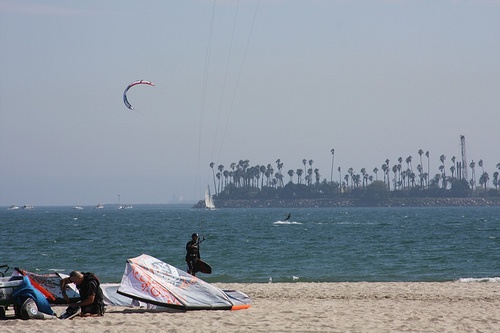Describe the objects in this image and their specific colors. I can see kite in darkgray, lightgray, and black tones, people in darkgray, black, gray, maroon, and lightgray tones, backpack in darkgray, black, gray, and navy tones, people in darkgray, black, gray, purple, and darkblue tones, and kite in darkgray, gray, and lightgray tones in this image. 